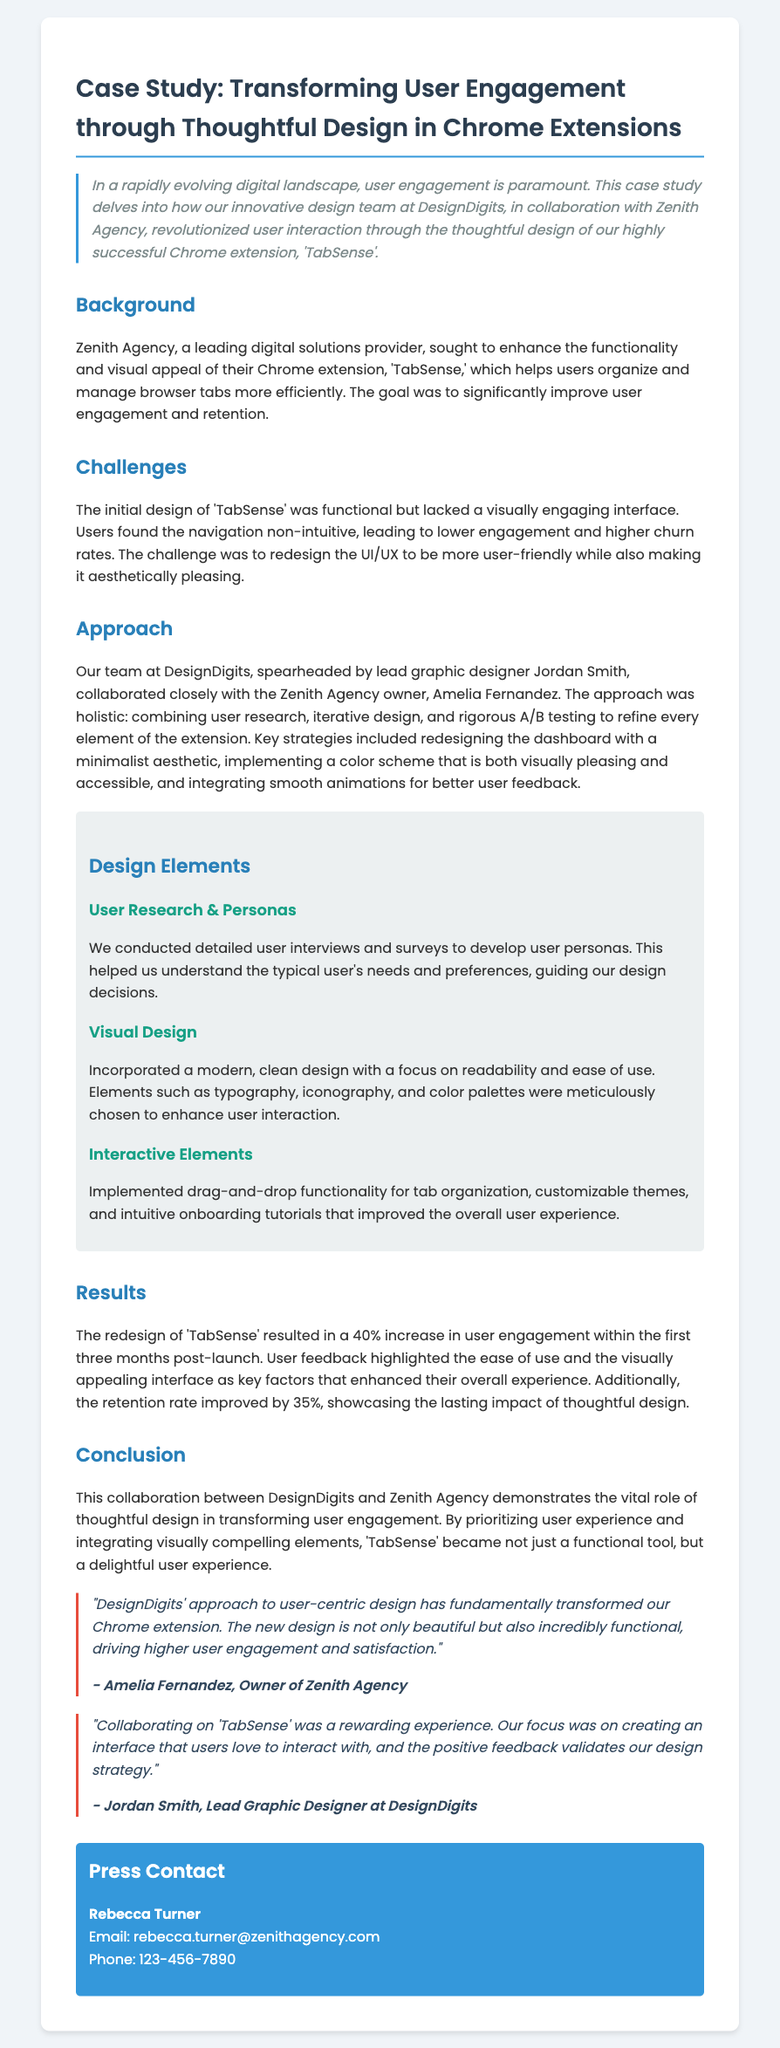What is the name of the Chrome extension discussed in the case study? The title mentions that the case study is about the Chrome extension named 'TabSense.'
Answer: 'TabSense' Who was the lead graphic designer involved in the project? The document cites Jordan Smith as the lead graphic designer for the redesign of 'TabSense.'
Answer: Jordan Smith What was the percentage increase in user engagement post-launch? The results section states that there was a 40% increase in user engagement within the first three months after the redesign.
Answer: 40% Who is the owner of Zenith Agency? The document contains a quote from Amelia Fernandez, who is identified as the owner of Zenith Agency.
Answer: Amelia Fernandez What design strategy was highlighted in the document? The approach emphasized a holistic combination of user research, iterative design, and rigorous A/B testing to improve the extension.
Answer: User research, iterative design, and A/B testing What improvement percentage was noted in retention rate? The case study indicates that retention rate improved by 35% after the redesign was implemented.
Answer: 35% What was one of the main challenges with the initial design of 'TabSense'? The document mentions that users found the navigation of the initial design to be non-intuitive, which contributed to lower engagement rates.
Answer: Non-intuitive navigation What type of feedback did the redesign of 'TabSense' generate from users? User feedback specifically highlighted ease of use and the visually appealing interface as key factors enhancing their overall experience.
Answer: Ease of use and visually appealing interface 